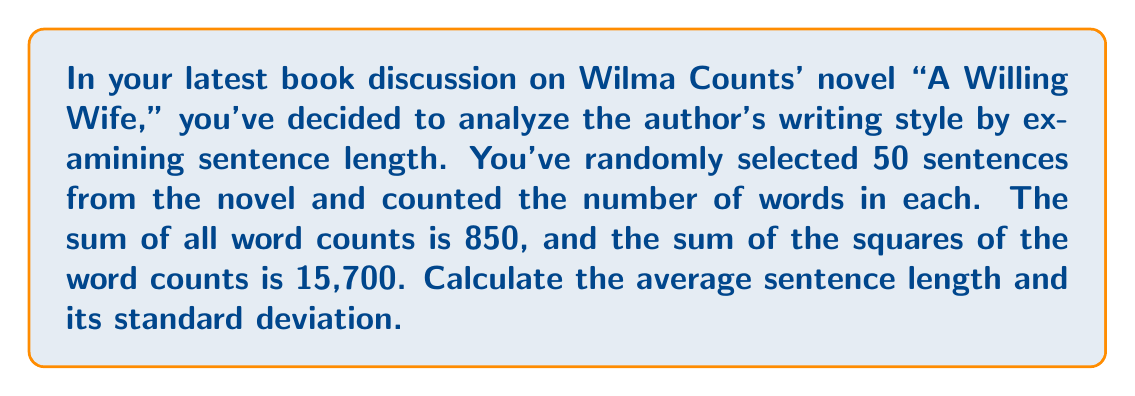Show me your answer to this math problem. Let's approach this step-by-step:

1) First, let's calculate the mean (average) sentence length.
   Let $n$ be the number of sentences and $\sum x$ be the sum of word counts.
   
   Mean $(\mu) = \frac{\sum x}{n} = \frac{850}{50} = 17$ words

2) To calculate the standard deviation, we'll use the formula:

   $\sigma = \sqrt{\frac{\sum x^2}{n} - \mu^2}$

   Where $\sum x^2$ is the sum of squared word counts.

3) We know that $\sum x^2 = 15,700$ and $n = 50$

4) Substituting these values:

   $\sigma = \sqrt{\frac{15,700}{50} - 17^2}$

5) Simplify:
   
   $\sigma = \sqrt{314 - 289}$
   
   $\sigma = \sqrt{25}$
   
   $\sigma = 5$ words

Therefore, the average sentence length is 17 words, with a standard deviation of 5 words.
Answer: Average sentence length: 17 words
Standard deviation: 5 words 